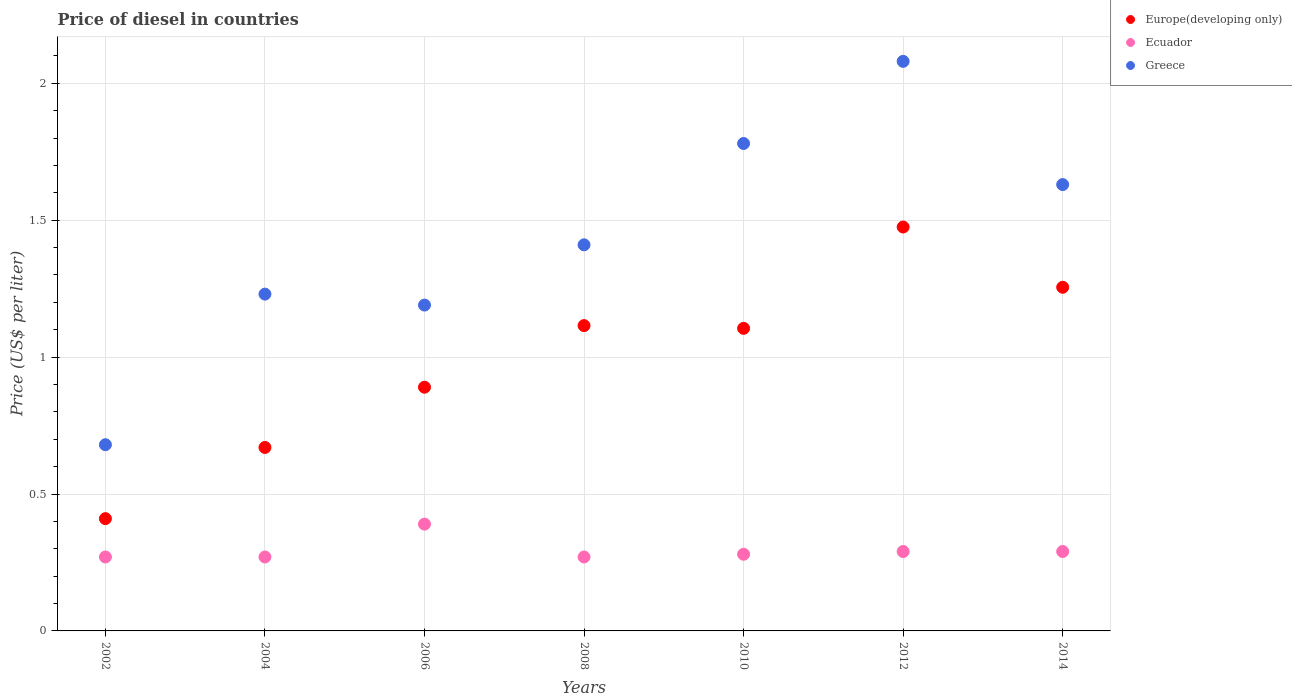How many different coloured dotlines are there?
Provide a short and direct response. 3. Is the number of dotlines equal to the number of legend labels?
Keep it short and to the point. Yes. What is the price of diesel in Greece in 2002?
Your answer should be very brief. 0.68. Across all years, what is the maximum price of diesel in Greece?
Make the answer very short. 2.08. Across all years, what is the minimum price of diesel in Greece?
Give a very brief answer. 0.68. In which year was the price of diesel in Europe(developing only) maximum?
Provide a short and direct response. 2012. What is the total price of diesel in Ecuador in the graph?
Give a very brief answer. 2.06. What is the difference between the price of diesel in Europe(developing only) in 2008 and that in 2012?
Ensure brevity in your answer.  -0.36. What is the difference between the price of diesel in Europe(developing only) in 2006 and the price of diesel in Greece in 2008?
Your answer should be compact. -0.52. What is the average price of diesel in Ecuador per year?
Your response must be concise. 0.29. In the year 2010, what is the difference between the price of diesel in Greece and price of diesel in Ecuador?
Keep it short and to the point. 1.5. What is the ratio of the price of diesel in Greece in 2002 to that in 2006?
Ensure brevity in your answer.  0.57. What is the difference between the highest and the second highest price of diesel in Europe(developing only)?
Your answer should be compact. 0.22. What is the difference between the highest and the lowest price of diesel in Europe(developing only)?
Provide a succinct answer. 1.07. Is it the case that in every year, the sum of the price of diesel in Europe(developing only) and price of diesel in Ecuador  is greater than the price of diesel in Greece?
Keep it short and to the point. No. Does the price of diesel in Europe(developing only) monotonically increase over the years?
Your answer should be compact. No. Is the price of diesel in Europe(developing only) strictly less than the price of diesel in Ecuador over the years?
Give a very brief answer. No. How many dotlines are there?
Keep it short and to the point. 3. How many years are there in the graph?
Offer a terse response. 7. How many legend labels are there?
Provide a succinct answer. 3. How are the legend labels stacked?
Provide a succinct answer. Vertical. What is the title of the graph?
Provide a short and direct response. Price of diesel in countries. Does "Turkmenistan" appear as one of the legend labels in the graph?
Your answer should be very brief. No. What is the label or title of the Y-axis?
Provide a succinct answer. Price (US$ per liter). What is the Price (US$ per liter) in Europe(developing only) in 2002?
Provide a succinct answer. 0.41. What is the Price (US$ per liter) in Ecuador in 2002?
Offer a very short reply. 0.27. What is the Price (US$ per liter) of Greece in 2002?
Provide a short and direct response. 0.68. What is the Price (US$ per liter) of Europe(developing only) in 2004?
Make the answer very short. 0.67. What is the Price (US$ per liter) of Ecuador in 2004?
Give a very brief answer. 0.27. What is the Price (US$ per liter) of Greece in 2004?
Offer a terse response. 1.23. What is the Price (US$ per liter) of Europe(developing only) in 2006?
Make the answer very short. 0.89. What is the Price (US$ per liter) in Ecuador in 2006?
Make the answer very short. 0.39. What is the Price (US$ per liter) of Greece in 2006?
Your answer should be very brief. 1.19. What is the Price (US$ per liter) in Europe(developing only) in 2008?
Offer a very short reply. 1.11. What is the Price (US$ per liter) of Ecuador in 2008?
Provide a succinct answer. 0.27. What is the Price (US$ per liter) in Greece in 2008?
Give a very brief answer. 1.41. What is the Price (US$ per liter) of Europe(developing only) in 2010?
Keep it short and to the point. 1.1. What is the Price (US$ per liter) in Ecuador in 2010?
Ensure brevity in your answer.  0.28. What is the Price (US$ per liter) in Greece in 2010?
Offer a terse response. 1.78. What is the Price (US$ per liter) in Europe(developing only) in 2012?
Provide a short and direct response. 1.48. What is the Price (US$ per liter) in Ecuador in 2012?
Keep it short and to the point. 0.29. What is the Price (US$ per liter) of Greece in 2012?
Your answer should be compact. 2.08. What is the Price (US$ per liter) of Europe(developing only) in 2014?
Your answer should be very brief. 1.25. What is the Price (US$ per liter) of Ecuador in 2014?
Ensure brevity in your answer.  0.29. What is the Price (US$ per liter) of Greece in 2014?
Your answer should be compact. 1.63. Across all years, what is the maximum Price (US$ per liter) of Europe(developing only)?
Give a very brief answer. 1.48. Across all years, what is the maximum Price (US$ per liter) in Ecuador?
Your answer should be compact. 0.39. Across all years, what is the maximum Price (US$ per liter) in Greece?
Offer a very short reply. 2.08. Across all years, what is the minimum Price (US$ per liter) in Europe(developing only)?
Offer a terse response. 0.41. Across all years, what is the minimum Price (US$ per liter) of Ecuador?
Offer a very short reply. 0.27. Across all years, what is the minimum Price (US$ per liter) of Greece?
Provide a short and direct response. 0.68. What is the total Price (US$ per liter) in Europe(developing only) in the graph?
Your answer should be compact. 6.92. What is the total Price (US$ per liter) of Ecuador in the graph?
Your answer should be very brief. 2.06. What is the total Price (US$ per liter) in Greece in the graph?
Your answer should be compact. 10. What is the difference between the Price (US$ per liter) in Europe(developing only) in 2002 and that in 2004?
Provide a short and direct response. -0.26. What is the difference between the Price (US$ per liter) in Greece in 2002 and that in 2004?
Your answer should be compact. -0.55. What is the difference between the Price (US$ per liter) of Europe(developing only) in 2002 and that in 2006?
Ensure brevity in your answer.  -0.48. What is the difference between the Price (US$ per liter) of Ecuador in 2002 and that in 2006?
Provide a succinct answer. -0.12. What is the difference between the Price (US$ per liter) in Greece in 2002 and that in 2006?
Offer a terse response. -0.51. What is the difference between the Price (US$ per liter) in Europe(developing only) in 2002 and that in 2008?
Keep it short and to the point. -0.7. What is the difference between the Price (US$ per liter) in Ecuador in 2002 and that in 2008?
Keep it short and to the point. 0. What is the difference between the Price (US$ per liter) in Greece in 2002 and that in 2008?
Your answer should be very brief. -0.73. What is the difference between the Price (US$ per liter) of Europe(developing only) in 2002 and that in 2010?
Make the answer very short. -0.69. What is the difference between the Price (US$ per liter) in Ecuador in 2002 and that in 2010?
Keep it short and to the point. -0.01. What is the difference between the Price (US$ per liter) in Europe(developing only) in 2002 and that in 2012?
Offer a terse response. -1.06. What is the difference between the Price (US$ per liter) in Ecuador in 2002 and that in 2012?
Offer a terse response. -0.02. What is the difference between the Price (US$ per liter) of Europe(developing only) in 2002 and that in 2014?
Ensure brevity in your answer.  -0.84. What is the difference between the Price (US$ per liter) in Ecuador in 2002 and that in 2014?
Your answer should be compact. -0.02. What is the difference between the Price (US$ per liter) in Greece in 2002 and that in 2014?
Provide a short and direct response. -0.95. What is the difference between the Price (US$ per liter) in Europe(developing only) in 2004 and that in 2006?
Keep it short and to the point. -0.22. What is the difference between the Price (US$ per liter) of Ecuador in 2004 and that in 2006?
Your answer should be very brief. -0.12. What is the difference between the Price (US$ per liter) in Europe(developing only) in 2004 and that in 2008?
Ensure brevity in your answer.  -0.45. What is the difference between the Price (US$ per liter) in Ecuador in 2004 and that in 2008?
Ensure brevity in your answer.  0. What is the difference between the Price (US$ per liter) in Greece in 2004 and that in 2008?
Ensure brevity in your answer.  -0.18. What is the difference between the Price (US$ per liter) of Europe(developing only) in 2004 and that in 2010?
Give a very brief answer. -0.43. What is the difference between the Price (US$ per liter) of Ecuador in 2004 and that in 2010?
Make the answer very short. -0.01. What is the difference between the Price (US$ per liter) of Greece in 2004 and that in 2010?
Ensure brevity in your answer.  -0.55. What is the difference between the Price (US$ per liter) of Europe(developing only) in 2004 and that in 2012?
Provide a succinct answer. -0.81. What is the difference between the Price (US$ per liter) of Ecuador in 2004 and that in 2012?
Keep it short and to the point. -0.02. What is the difference between the Price (US$ per liter) in Greece in 2004 and that in 2012?
Offer a terse response. -0.85. What is the difference between the Price (US$ per liter) of Europe(developing only) in 2004 and that in 2014?
Your response must be concise. -0.58. What is the difference between the Price (US$ per liter) of Ecuador in 2004 and that in 2014?
Your answer should be very brief. -0.02. What is the difference between the Price (US$ per liter) of Greece in 2004 and that in 2014?
Your answer should be very brief. -0.4. What is the difference between the Price (US$ per liter) in Europe(developing only) in 2006 and that in 2008?
Provide a succinct answer. -0.23. What is the difference between the Price (US$ per liter) in Ecuador in 2006 and that in 2008?
Provide a succinct answer. 0.12. What is the difference between the Price (US$ per liter) in Greece in 2006 and that in 2008?
Your answer should be very brief. -0.22. What is the difference between the Price (US$ per liter) in Europe(developing only) in 2006 and that in 2010?
Your response must be concise. -0.21. What is the difference between the Price (US$ per liter) in Ecuador in 2006 and that in 2010?
Make the answer very short. 0.11. What is the difference between the Price (US$ per liter) in Greece in 2006 and that in 2010?
Keep it short and to the point. -0.59. What is the difference between the Price (US$ per liter) in Europe(developing only) in 2006 and that in 2012?
Provide a succinct answer. -0.58. What is the difference between the Price (US$ per liter) of Ecuador in 2006 and that in 2012?
Give a very brief answer. 0.1. What is the difference between the Price (US$ per liter) of Greece in 2006 and that in 2012?
Provide a short and direct response. -0.89. What is the difference between the Price (US$ per liter) of Europe(developing only) in 2006 and that in 2014?
Ensure brevity in your answer.  -0.36. What is the difference between the Price (US$ per liter) of Greece in 2006 and that in 2014?
Give a very brief answer. -0.44. What is the difference between the Price (US$ per liter) of Europe(developing only) in 2008 and that in 2010?
Ensure brevity in your answer.  0.01. What is the difference between the Price (US$ per liter) in Ecuador in 2008 and that in 2010?
Your answer should be compact. -0.01. What is the difference between the Price (US$ per liter) of Greece in 2008 and that in 2010?
Give a very brief answer. -0.37. What is the difference between the Price (US$ per liter) of Europe(developing only) in 2008 and that in 2012?
Your answer should be very brief. -0.36. What is the difference between the Price (US$ per liter) of Ecuador in 2008 and that in 2012?
Give a very brief answer. -0.02. What is the difference between the Price (US$ per liter) in Greece in 2008 and that in 2012?
Offer a very short reply. -0.67. What is the difference between the Price (US$ per liter) in Europe(developing only) in 2008 and that in 2014?
Keep it short and to the point. -0.14. What is the difference between the Price (US$ per liter) in Ecuador in 2008 and that in 2014?
Your answer should be very brief. -0.02. What is the difference between the Price (US$ per liter) in Greece in 2008 and that in 2014?
Provide a succinct answer. -0.22. What is the difference between the Price (US$ per liter) in Europe(developing only) in 2010 and that in 2012?
Give a very brief answer. -0.37. What is the difference between the Price (US$ per liter) in Ecuador in 2010 and that in 2012?
Ensure brevity in your answer.  -0.01. What is the difference between the Price (US$ per liter) in Europe(developing only) in 2010 and that in 2014?
Ensure brevity in your answer.  -0.15. What is the difference between the Price (US$ per liter) of Ecuador in 2010 and that in 2014?
Offer a terse response. -0.01. What is the difference between the Price (US$ per liter) in Europe(developing only) in 2012 and that in 2014?
Provide a succinct answer. 0.22. What is the difference between the Price (US$ per liter) in Greece in 2012 and that in 2014?
Ensure brevity in your answer.  0.45. What is the difference between the Price (US$ per liter) in Europe(developing only) in 2002 and the Price (US$ per liter) in Ecuador in 2004?
Offer a very short reply. 0.14. What is the difference between the Price (US$ per liter) in Europe(developing only) in 2002 and the Price (US$ per liter) in Greece in 2004?
Your response must be concise. -0.82. What is the difference between the Price (US$ per liter) of Ecuador in 2002 and the Price (US$ per liter) of Greece in 2004?
Offer a terse response. -0.96. What is the difference between the Price (US$ per liter) in Europe(developing only) in 2002 and the Price (US$ per liter) in Ecuador in 2006?
Provide a short and direct response. 0.02. What is the difference between the Price (US$ per liter) of Europe(developing only) in 2002 and the Price (US$ per liter) of Greece in 2006?
Make the answer very short. -0.78. What is the difference between the Price (US$ per liter) of Ecuador in 2002 and the Price (US$ per liter) of Greece in 2006?
Your response must be concise. -0.92. What is the difference between the Price (US$ per liter) of Europe(developing only) in 2002 and the Price (US$ per liter) of Ecuador in 2008?
Offer a very short reply. 0.14. What is the difference between the Price (US$ per liter) in Europe(developing only) in 2002 and the Price (US$ per liter) in Greece in 2008?
Offer a terse response. -1. What is the difference between the Price (US$ per liter) of Ecuador in 2002 and the Price (US$ per liter) of Greece in 2008?
Offer a terse response. -1.14. What is the difference between the Price (US$ per liter) in Europe(developing only) in 2002 and the Price (US$ per liter) in Ecuador in 2010?
Make the answer very short. 0.13. What is the difference between the Price (US$ per liter) of Europe(developing only) in 2002 and the Price (US$ per liter) of Greece in 2010?
Make the answer very short. -1.37. What is the difference between the Price (US$ per liter) in Ecuador in 2002 and the Price (US$ per liter) in Greece in 2010?
Offer a terse response. -1.51. What is the difference between the Price (US$ per liter) in Europe(developing only) in 2002 and the Price (US$ per liter) in Ecuador in 2012?
Offer a very short reply. 0.12. What is the difference between the Price (US$ per liter) of Europe(developing only) in 2002 and the Price (US$ per liter) of Greece in 2012?
Ensure brevity in your answer.  -1.67. What is the difference between the Price (US$ per liter) of Ecuador in 2002 and the Price (US$ per liter) of Greece in 2012?
Provide a short and direct response. -1.81. What is the difference between the Price (US$ per liter) of Europe(developing only) in 2002 and the Price (US$ per liter) of Ecuador in 2014?
Offer a very short reply. 0.12. What is the difference between the Price (US$ per liter) of Europe(developing only) in 2002 and the Price (US$ per liter) of Greece in 2014?
Provide a succinct answer. -1.22. What is the difference between the Price (US$ per liter) in Ecuador in 2002 and the Price (US$ per liter) in Greece in 2014?
Ensure brevity in your answer.  -1.36. What is the difference between the Price (US$ per liter) of Europe(developing only) in 2004 and the Price (US$ per liter) of Ecuador in 2006?
Provide a succinct answer. 0.28. What is the difference between the Price (US$ per liter) in Europe(developing only) in 2004 and the Price (US$ per liter) in Greece in 2006?
Ensure brevity in your answer.  -0.52. What is the difference between the Price (US$ per liter) in Ecuador in 2004 and the Price (US$ per liter) in Greece in 2006?
Your answer should be very brief. -0.92. What is the difference between the Price (US$ per liter) of Europe(developing only) in 2004 and the Price (US$ per liter) of Greece in 2008?
Make the answer very short. -0.74. What is the difference between the Price (US$ per liter) of Ecuador in 2004 and the Price (US$ per liter) of Greece in 2008?
Your response must be concise. -1.14. What is the difference between the Price (US$ per liter) in Europe(developing only) in 2004 and the Price (US$ per liter) in Ecuador in 2010?
Provide a succinct answer. 0.39. What is the difference between the Price (US$ per liter) of Europe(developing only) in 2004 and the Price (US$ per liter) of Greece in 2010?
Make the answer very short. -1.11. What is the difference between the Price (US$ per liter) of Ecuador in 2004 and the Price (US$ per liter) of Greece in 2010?
Make the answer very short. -1.51. What is the difference between the Price (US$ per liter) of Europe(developing only) in 2004 and the Price (US$ per liter) of Ecuador in 2012?
Provide a succinct answer. 0.38. What is the difference between the Price (US$ per liter) of Europe(developing only) in 2004 and the Price (US$ per liter) of Greece in 2012?
Offer a very short reply. -1.41. What is the difference between the Price (US$ per liter) of Ecuador in 2004 and the Price (US$ per liter) of Greece in 2012?
Give a very brief answer. -1.81. What is the difference between the Price (US$ per liter) of Europe(developing only) in 2004 and the Price (US$ per liter) of Ecuador in 2014?
Give a very brief answer. 0.38. What is the difference between the Price (US$ per liter) of Europe(developing only) in 2004 and the Price (US$ per liter) of Greece in 2014?
Your answer should be compact. -0.96. What is the difference between the Price (US$ per liter) of Ecuador in 2004 and the Price (US$ per liter) of Greece in 2014?
Your answer should be compact. -1.36. What is the difference between the Price (US$ per liter) of Europe(developing only) in 2006 and the Price (US$ per liter) of Ecuador in 2008?
Provide a succinct answer. 0.62. What is the difference between the Price (US$ per liter) in Europe(developing only) in 2006 and the Price (US$ per liter) in Greece in 2008?
Give a very brief answer. -0.52. What is the difference between the Price (US$ per liter) of Ecuador in 2006 and the Price (US$ per liter) of Greece in 2008?
Offer a terse response. -1.02. What is the difference between the Price (US$ per liter) of Europe(developing only) in 2006 and the Price (US$ per liter) of Ecuador in 2010?
Provide a short and direct response. 0.61. What is the difference between the Price (US$ per liter) of Europe(developing only) in 2006 and the Price (US$ per liter) of Greece in 2010?
Offer a terse response. -0.89. What is the difference between the Price (US$ per liter) in Ecuador in 2006 and the Price (US$ per liter) in Greece in 2010?
Your answer should be very brief. -1.39. What is the difference between the Price (US$ per liter) in Europe(developing only) in 2006 and the Price (US$ per liter) in Ecuador in 2012?
Make the answer very short. 0.6. What is the difference between the Price (US$ per liter) of Europe(developing only) in 2006 and the Price (US$ per liter) of Greece in 2012?
Provide a short and direct response. -1.19. What is the difference between the Price (US$ per liter) in Ecuador in 2006 and the Price (US$ per liter) in Greece in 2012?
Provide a succinct answer. -1.69. What is the difference between the Price (US$ per liter) of Europe(developing only) in 2006 and the Price (US$ per liter) of Greece in 2014?
Give a very brief answer. -0.74. What is the difference between the Price (US$ per liter) in Ecuador in 2006 and the Price (US$ per liter) in Greece in 2014?
Your answer should be compact. -1.24. What is the difference between the Price (US$ per liter) of Europe(developing only) in 2008 and the Price (US$ per liter) of Ecuador in 2010?
Your answer should be compact. 0.83. What is the difference between the Price (US$ per liter) in Europe(developing only) in 2008 and the Price (US$ per liter) in Greece in 2010?
Provide a succinct answer. -0.67. What is the difference between the Price (US$ per liter) of Ecuador in 2008 and the Price (US$ per liter) of Greece in 2010?
Your answer should be very brief. -1.51. What is the difference between the Price (US$ per liter) of Europe(developing only) in 2008 and the Price (US$ per liter) of Ecuador in 2012?
Ensure brevity in your answer.  0.82. What is the difference between the Price (US$ per liter) in Europe(developing only) in 2008 and the Price (US$ per liter) in Greece in 2012?
Your answer should be very brief. -0.96. What is the difference between the Price (US$ per liter) in Ecuador in 2008 and the Price (US$ per liter) in Greece in 2012?
Make the answer very short. -1.81. What is the difference between the Price (US$ per liter) in Europe(developing only) in 2008 and the Price (US$ per liter) in Ecuador in 2014?
Keep it short and to the point. 0.82. What is the difference between the Price (US$ per liter) of Europe(developing only) in 2008 and the Price (US$ per liter) of Greece in 2014?
Offer a very short reply. -0.52. What is the difference between the Price (US$ per liter) of Ecuador in 2008 and the Price (US$ per liter) of Greece in 2014?
Keep it short and to the point. -1.36. What is the difference between the Price (US$ per liter) in Europe(developing only) in 2010 and the Price (US$ per liter) in Ecuador in 2012?
Ensure brevity in your answer.  0.81. What is the difference between the Price (US$ per liter) in Europe(developing only) in 2010 and the Price (US$ per liter) in Greece in 2012?
Provide a short and direct response. -0.97. What is the difference between the Price (US$ per liter) of Ecuador in 2010 and the Price (US$ per liter) of Greece in 2012?
Give a very brief answer. -1.8. What is the difference between the Price (US$ per liter) of Europe(developing only) in 2010 and the Price (US$ per liter) of Ecuador in 2014?
Make the answer very short. 0.81. What is the difference between the Price (US$ per liter) in Europe(developing only) in 2010 and the Price (US$ per liter) in Greece in 2014?
Make the answer very short. -0.53. What is the difference between the Price (US$ per liter) in Ecuador in 2010 and the Price (US$ per liter) in Greece in 2014?
Offer a very short reply. -1.35. What is the difference between the Price (US$ per liter) of Europe(developing only) in 2012 and the Price (US$ per liter) of Ecuador in 2014?
Provide a succinct answer. 1.19. What is the difference between the Price (US$ per liter) in Europe(developing only) in 2012 and the Price (US$ per liter) in Greece in 2014?
Your response must be concise. -0.15. What is the difference between the Price (US$ per liter) of Ecuador in 2012 and the Price (US$ per liter) of Greece in 2014?
Offer a terse response. -1.34. What is the average Price (US$ per liter) in Europe(developing only) per year?
Ensure brevity in your answer.  0.99. What is the average Price (US$ per liter) in Ecuador per year?
Your response must be concise. 0.29. What is the average Price (US$ per liter) of Greece per year?
Give a very brief answer. 1.43. In the year 2002, what is the difference between the Price (US$ per liter) in Europe(developing only) and Price (US$ per liter) in Ecuador?
Make the answer very short. 0.14. In the year 2002, what is the difference between the Price (US$ per liter) in Europe(developing only) and Price (US$ per liter) in Greece?
Keep it short and to the point. -0.27. In the year 2002, what is the difference between the Price (US$ per liter) of Ecuador and Price (US$ per liter) of Greece?
Your answer should be very brief. -0.41. In the year 2004, what is the difference between the Price (US$ per liter) in Europe(developing only) and Price (US$ per liter) in Greece?
Make the answer very short. -0.56. In the year 2004, what is the difference between the Price (US$ per liter) of Ecuador and Price (US$ per liter) of Greece?
Make the answer very short. -0.96. In the year 2006, what is the difference between the Price (US$ per liter) of Europe(developing only) and Price (US$ per liter) of Greece?
Keep it short and to the point. -0.3. In the year 2006, what is the difference between the Price (US$ per liter) in Ecuador and Price (US$ per liter) in Greece?
Your answer should be compact. -0.8. In the year 2008, what is the difference between the Price (US$ per liter) in Europe(developing only) and Price (US$ per liter) in Ecuador?
Provide a short and direct response. 0.84. In the year 2008, what is the difference between the Price (US$ per liter) of Europe(developing only) and Price (US$ per liter) of Greece?
Make the answer very short. -0.29. In the year 2008, what is the difference between the Price (US$ per liter) of Ecuador and Price (US$ per liter) of Greece?
Offer a terse response. -1.14. In the year 2010, what is the difference between the Price (US$ per liter) of Europe(developing only) and Price (US$ per liter) of Ecuador?
Offer a very short reply. 0.82. In the year 2010, what is the difference between the Price (US$ per liter) in Europe(developing only) and Price (US$ per liter) in Greece?
Give a very brief answer. -0.68. In the year 2010, what is the difference between the Price (US$ per liter) of Ecuador and Price (US$ per liter) of Greece?
Your response must be concise. -1.5. In the year 2012, what is the difference between the Price (US$ per liter) in Europe(developing only) and Price (US$ per liter) in Ecuador?
Keep it short and to the point. 1.19. In the year 2012, what is the difference between the Price (US$ per liter) in Europe(developing only) and Price (US$ per liter) in Greece?
Offer a very short reply. -0.6. In the year 2012, what is the difference between the Price (US$ per liter) in Ecuador and Price (US$ per liter) in Greece?
Provide a short and direct response. -1.79. In the year 2014, what is the difference between the Price (US$ per liter) in Europe(developing only) and Price (US$ per liter) in Ecuador?
Ensure brevity in your answer.  0.96. In the year 2014, what is the difference between the Price (US$ per liter) of Europe(developing only) and Price (US$ per liter) of Greece?
Keep it short and to the point. -0.38. In the year 2014, what is the difference between the Price (US$ per liter) of Ecuador and Price (US$ per liter) of Greece?
Offer a terse response. -1.34. What is the ratio of the Price (US$ per liter) in Europe(developing only) in 2002 to that in 2004?
Provide a short and direct response. 0.61. What is the ratio of the Price (US$ per liter) in Ecuador in 2002 to that in 2004?
Your answer should be very brief. 1. What is the ratio of the Price (US$ per liter) of Greece in 2002 to that in 2004?
Provide a short and direct response. 0.55. What is the ratio of the Price (US$ per liter) of Europe(developing only) in 2002 to that in 2006?
Your response must be concise. 0.46. What is the ratio of the Price (US$ per liter) of Ecuador in 2002 to that in 2006?
Give a very brief answer. 0.69. What is the ratio of the Price (US$ per liter) of Greece in 2002 to that in 2006?
Your answer should be compact. 0.57. What is the ratio of the Price (US$ per liter) in Europe(developing only) in 2002 to that in 2008?
Your response must be concise. 0.37. What is the ratio of the Price (US$ per liter) in Greece in 2002 to that in 2008?
Your answer should be compact. 0.48. What is the ratio of the Price (US$ per liter) in Europe(developing only) in 2002 to that in 2010?
Keep it short and to the point. 0.37. What is the ratio of the Price (US$ per liter) in Ecuador in 2002 to that in 2010?
Make the answer very short. 0.96. What is the ratio of the Price (US$ per liter) of Greece in 2002 to that in 2010?
Your answer should be very brief. 0.38. What is the ratio of the Price (US$ per liter) in Europe(developing only) in 2002 to that in 2012?
Ensure brevity in your answer.  0.28. What is the ratio of the Price (US$ per liter) of Greece in 2002 to that in 2012?
Provide a succinct answer. 0.33. What is the ratio of the Price (US$ per liter) in Europe(developing only) in 2002 to that in 2014?
Your answer should be very brief. 0.33. What is the ratio of the Price (US$ per liter) in Greece in 2002 to that in 2014?
Offer a terse response. 0.42. What is the ratio of the Price (US$ per liter) of Europe(developing only) in 2004 to that in 2006?
Your response must be concise. 0.75. What is the ratio of the Price (US$ per liter) of Ecuador in 2004 to that in 2006?
Provide a short and direct response. 0.69. What is the ratio of the Price (US$ per liter) in Greece in 2004 to that in 2006?
Your response must be concise. 1.03. What is the ratio of the Price (US$ per liter) of Europe(developing only) in 2004 to that in 2008?
Give a very brief answer. 0.6. What is the ratio of the Price (US$ per liter) in Greece in 2004 to that in 2008?
Provide a short and direct response. 0.87. What is the ratio of the Price (US$ per liter) of Europe(developing only) in 2004 to that in 2010?
Offer a very short reply. 0.61. What is the ratio of the Price (US$ per liter) in Ecuador in 2004 to that in 2010?
Provide a succinct answer. 0.96. What is the ratio of the Price (US$ per liter) in Greece in 2004 to that in 2010?
Your response must be concise. 0.69. What is the ratio of the Price (US$ per liter) in Europe(developing only) in 2004 to that in 2012?
Your response must be concise. 0.45. What is the ratio of the Price (US$ per liter) of Greece in 2004 to that in 2012?
Ensure brevity in your answer.  0.59. What is the ratio of the Price (US$ per liter) of Europe(developing only) in 2004 to that in 2014?
Offer a terse response. 0.53. What is the ratio of the Price (US$ per liter) in Greece in 2004 to that in 2014?
Your answer should be very brief. 0.75. What is the ratio of the Price (US$ per liter) in Europe(developing only) in 2006 to that in 2008?
Your response must be concise. 0.8. What is the ratio of the Price (US$ per liter) in Ecuador in 2006 to that in 2008?
Give a very brief answer. 1.44. What is the ratio of the Price (US$ per liter) in Greece in 2006 to that in 2008?
Offer a terse response. 0.84. What is the ratio of the Price (US$ per liter) of Europe(developing only) in 2006 to that in 2010?
Offer a very short reply. 0.81. What is the ratio of the Price (US$ per liter) in Ecuador in 2006 to that in 2010?
Provide a short and direct response. 1.39. What is the ratio of the Price (US$ per liter) of Greece in 2006 to that in 2010?
Provide a succinct answer. 0.67. What is the ratio of the Price (US$ per liter) of Europe(developing only) in 2006 to that in 2012?
Your answer should be very brief. 0.6. What is the ratio of the Price (US$ per liter) of Ecuador in 2006 to that in 2012?
Your answer should be compact. 1.34. What is the ratio of the Price (US$ per liter) in Greece in 2006 to that in 2012?
Your response must be concise. 0.57. What is the ratio of the Price (US$ per liter) of Europe(developing only) in 2006 to that in 2014?
Make the answer very short. 0.71. What is the ratio of the Price (US$ per liter) of Ecuador in 2006 to that in 2014?
Your answer should be very brief. 1.34. What is the ratio of the Price (US$ per liter) in Greece in 2006 to that in 2014?
Provide a succinct answer. 0.73. What is the ratio of the Price (US$ per liter) in Europe(developing only) in 2008 to that in 2010?
Your answer should be compact. 1.01. What is the ratio of the Price (US$ per liter) in Ecuador in 2008 to that in 2010?
Your answer should be very brief. 0.96. What is the ratio of the Price (US$ per liter) of Greece in 2008 to that in 2010?
Ensure brevity in your answer.  0.79. What is the ratio of the Price (US$ per liter) of Europe(developing only) in 2008 to that in 2012?
Provide a short and direct response. 0.76. What is the ratio of the Price (US$ per liter) of Greece in 2008 to that in 2012?
Keep it short and to the point. 0.68. What is the ratio of the Price (US$ per liter) of Europe(developing only) in 2008 to that in 2014?
Give a very brief answer. 0.89. What is the ratio of the Price (US$ per liter) in Greece in 2008 to that in 2014?
Provide a succinct answer. 0.86. What is the ratio of the Price (US$ per liter) of Europe(developing only) in 2010 to that in 2012?
Offer a very short reply. 0.75. What is the ratio of the Price (US$ per liter) of Ecuador in 2010 to that in 2012?
Offer a very short reply. 0.97. What is the ratio of the Price (US$ per liter) in Greece in 2010 to that in 2012?
Make the answer very short. 0.86. What is the ratio of the Price (US$ per liter) of Europe(developing only) in 2010 to that in 2014?
Provide a succinct answer. 0.88. What is the ratio of the Price (US$ per liter) in Ecuador in 2010 to that in 2014?
Offer a terse response. 0.97. What is the ratio of the Price (US$ per liter) of Greece in 2010 to that in 2014?
Ensure brevity in your answer.  1.09. What is the ratio of the Price (US$ per liter) of Europe(developing only) in 2012 to that in 2014?
Your answer should be compact. 1.18. What is the ratio of the Price (US$ per liter) of Ecuador in 2012 to that in 2014?
Provide a short and direct response. 1. What is the ratio of the Price (US$ per liter) in Greece in 2012 to that in 2014?
Provide a succinct answer. 1.28. What is the difference between the highest and the second highest Price (US$ per liter) in Europe(developing only)?
Give a very brief answer. 0.22. What is the difference between the highest and the second highest Price (US$ per liter) in Ecuador?
Offer a very short reply. 0.1. What is the difference between the highest and the second highest Price (US$ per liter) of Greece?
Ensure brevity in your answer.  0.3. What is the difference between the highest and the lowest Price (US$ per liter) in Europe(developing only)?
Make the answer very short. 1.06. What is the difference between the highest and the lowest Price (US$ per liter) of Ecuador?
Your response must be concise. 0.12. What is the difference between the highest and the lowest Price (US$ per liter) in Greece?
Provide a succinct answer. 1.4. 